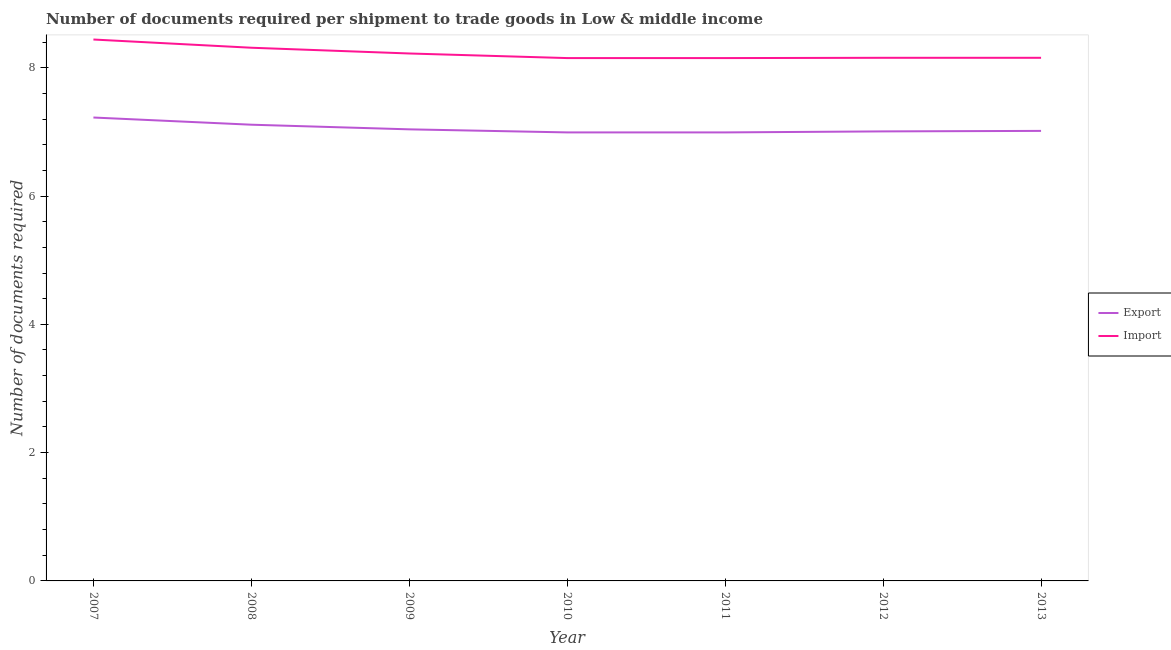How many different coloured lines are there?
Keep it short and to the point. 2. Does the line corresponding to number of documents required to import goods intersect with the line corresponding to number of documents required to export goods?
Make the answer very short. No. What is the number of documents required to export goods in 2009?
Provide a succinct answer. 7.04. Across all years, what is the maximum number of documents required to export goods?
Make the answer very short. 7.22. Across all years, what is the minimum number of documents required to import goods?
Ensure brevity in your answer.  8.15. In which year was the number of documents required to import goods minimum?
Make the answer very short. 2010. What is the total number of documents required to export goods in the graph?
Give a very brief answer. 49.38. What is the difference between the number of documents required to import goods in 2009 and that in 2013?
Your answer should be compact. 0.07. What is the difference between the number of documents required to export goods in 2012 and the number of documents required to import goods in 2007?
Keep it short and to the point. -1.43. What is the average number of documents required to import goods per year?
Your response must be concise. 8.23. In the year 2008, what is the difference between the number of documents required to export goods and number of documents required to import goods?
Offer a terse response. -1.2. In how many years, is the number of documents required to import goods greater than 2?
Give a very brief answer. 7. What is the ratio of the number of documents required to import goods in 2007 to that in 2010?
Ensure brevity in your answer.  1.04. Is the number of documents required to export goods in 2010 less than that in 2011?
Your answer should be compact. No. Is the difference between the number of documents required to export goods in 2008 and 2013 greater than the difference between the number of documents required to import goods in 2008 and 2013?
Your answer should be very brief. No. What is the difference between the highest and the second highest number of documents required to export goods?
Make the answer very short. 0.11. What is the difference between the highest and the lowest number of documents required to import goods?
Provide a short and direct response. 0.29. How many years are there in the graph?
Your response must be concise. 7. What is the difference between two consecutive major ticks on the Y-axis?
Make the answer very short. 2. Does the graph contain any zero values?
Offer a very short reply. No. Does the graph contain grids?
Ensure brevity in your answer.  No. What is the title of the graph?
Provide a short and direct response. Number of documents required per shipment to trade goods in Low & middle income. What is the label or title of the Y-axis?
Ensure brevity in your answer.  Number of documents required. What is the Number of documents required in Export in 2007?
Offer a terse response. 7.22. What is the Number of documents required of Import in 2007?
Provide a short and direct response. 8.44. What is the Number of documents required in Export in 2008?
Provide a short and direct response. 7.11. What is the Number of documents required in Import in 2008?
Your answer should be compact. 8.31. What is the Number of documents required in Export in 2009?
Provide a succinct answer. 7.04. What is the Number of documents required of Import in 2009?
Your answer should be very brief. 8.22. What is the Number of documents required of Export in 2010?
Offer a terse response. 6.99. What is the Number of documents required of Import in 2010?
Your answer should be compact. 8.15. What is the Number of documents required in Export in 2011?
Provide a short and direct response. 6.99. What is the Number of documents required in Import in 2011?
Your answer should be compact. 8.15. What is the Number of documents required of Export in 2012?
Make the answer very short. 7.01. What is the Number of documents required of Import in 2012?
Your response must be concise. 8.16. What is the Number of documents required in Export in 2013?
Keep it short and to the point. 7.02. What is the Number of documents required in Import in 2013?
Make the answer very short. 8.16. Across all years, what is the maximum Number of documents required of Export?
Provide a succinct answer. 7.22. Across all years, what is the maximum Number of documents required of Import?
Your answer should be very brief. 8.44. Across all years, what is the minimum Number of documents required of Export?
Offer a terse response. 6.99. Across all years, what is the minimum Number of documents required in Import?
Make the answer very short. 8.15. What is the total Number of documents required of Export in the graph?
Keep it short and to the point. 49.38. What is the total Number of documents required of Import in the graph?
Ensure brevity in your answer.  57.59. What is the difference between the Number of documents required in Export in 2007 and that in 2008?
Your response must be concise. 0.11. What is the difference between the Number of documents required of Import in 2007 and that in 2008?
Offer a terse response. 0.13. What is the difference between the Number of documents required in Export in 2007 and that in 2009?
Your answer should be very brief. 0.18. What is the difference between the Number of documents required in Import in 2007 and that in 2009?
Ensure brevity in your answer.  0.22. What is the difference between the Number of documents required in Export in 2007 and that in 2010?
Ensure brevity in your answer.  0.23. What is the difference between the Number of documents required of Import in 2007 and that in 2010?
Provide a short and direct response. 0.29. What is the difference between the Number of documents required of Export in 2007 and that in 2011?
Ensure brevity in your answer.  0.23. What is the difference between the Number of documents required in Import in 2007 and that in 2011?
Provide a short and direct response. 0.29. What is the difference between the Number of documents required of Export in 2007 and that in 2012?
Offer a very short reply. 0.22. What is the difference between the Number of documents required in Import in 2007 and that in 2012?
Make the answer very short. 0.28. What is the difference between the Number of documents required in Export in 2007 and that in 2013?
Make the answer very short. 0.21. What is the difference between the Number of documents required in Import in 2007 and that in 2013?
Your answer should be compact. 0.28. What is the difference between the Number of documents required of Export in 2008 and that in 2009?
Your answer should be compact. 0.07. What is the difference between the Number of documents required in Import in 2008 and that in 2009?
Offer a terse response. 0.09. What is the difference between the Number of documents required in Export in 2008 and that in 2010?
Give a very brief answer. 0.12. What is the difference between the Number of documents required of Import in 2008 and that in 2010?
Make the answer very short. 0.16. What is the difference between the Number of documents required of Export in 2008 and that in 2011?
Your response must be concise. 0.12. What is the difference between the Number of documents required of Import in 2008 and that in 2011?
Keep it short and to the point. 0.16. What is the difference between the Number of documents required of Export in 2008 and that in 2012?
Provide a short and direct response. 0.1. What is the difference between the Number of documents required in Import in 2008 and that in 2012?
Offer a very short reply. 0.16. What is the difference between the Number of documents required of Export in 2008 and that in 2013?
Make the answer very short. 0.1. What is the difference between the Number of documents required in Import in 2008 and that in 2013?
Provide a succinct answer. 0.16. What is the difference between the Number of documents required in Export in 2009 and that in 2010?
Provide a short and direct response. 0.05. What is the difference between the Number of documents required in Import in 2009 and that in 2010?
Offer a very short reply. 0.07. What is the difference between the Number of documents required of Export in 2009 and that in 2011?
Provide a short and direct response. 0.05. What is the difference between the Number of documents required in Import in 2009 and that in 2011?
Ensure brevity in your answer.  0.07. What is the difference between the Number of documents required of Export in 2009 and that in 2012?
Your answer should be very brief. 0.03. What is the difference between the Number of documents required in Import in 2009 and that in 2012?
Ensure brevity in your answer.  0.07. What is the difference between the Number of documents required in Export in 2009 and that in 2013?
Ensure brevity in your answer.  0.02. What is the difference between the Number of documents required in Import in 2009 and that in 2013?
Offer a terse response. 0.07. What is the difference between the Number of documents required in Export in 2010 and that in 2011?
Your answer should be compact. 0. What is the difference between the Number of documents required in Import in 2010 and that in 2011?
Make the answer very short. 0. What is the difference between the Number of documents required in Export in 2010 and that in 2012?
Offer a very short reply. -0.02. What is the difference between the Number of documents required in Import in 2010 and that in 2012?
Make the answer very short. -0. What is the difference between the Number of documents required in Export in 2010 and that in 2013?
Your answer should be compact. -0.02. What is the difference between the Number of documents required in Import in 2010 and that in 2013?
Your answer should be compact. -0. What is the difference between the Number of documents required in Export in 2011 and that in 2012?
Keep it short and to the point. -0.02. What is the difference between the Number of documents required of Import in 2011 and that in 2012?
Offer a very short reply. -0. What is the difference between the Number of documents required in Export in 2011 and that in 2013?
Make the answer very short. -0.02. What is the difference between the Number of documents required in Import in 2011 and that in 2013?
Offer a very short reply. -0. What is the difference between the Number of documents required in Export in 2012 and that in 2013?
Keep it short and to the point. -0.01. What is the difference between the Number of documents required in Export in 2007 and the Number of documents required in Import in 2008?
Your response must be concise. -1.09. What is the difference between the Number of documents required of Export in 2007 and the Number of documents required of Import in 2009?
Keep it short and to the point. -1. What is the difference between the Number of documents required of Export in 2007 and the Number of documents required of Import in 2010?
Provide a succinct answer. -0.93. What is the difference between the Number of documents required in Export in 2007 and the Number of documents required in Import in 2011?
Your response must be concise. -0.93. What is the difference between the Number of documents required of Export in 2007 and the Number of documents required of Import in 2012?
Your response must be concise. -0.93. What is the difference between the Number of documents required of Export in 2007 and the Number of documents required of Import in 2013?
Your answer should be compact. -0.93. What is the difference between the Number of documents required of Export in 2008 and the Number of documents required of Import in 2009?
Give a very brief answer. -1.11. What is the difference between the Number of documents required in Export in 2008 and the Number of documents required in Import in 2010?
Offer a terse response. -1.04. What is the difference between the Number of documents required of Export in 2008 and the Number of documents required of Import in 2011?
Give a very brief answer. -1.04. What is the difference between the Number of documents required of Export in 2008 and the Number of documents required of Import in 2012?
Provide a succinct answer. -1.04. What is the difference between the Number of documents required in Export in 2008 and the Number of documents required in Import in 2013?
Your answer should be very brief. -1.04. What is the difference between the Number of documents required of Export in 2009 and the Number of documents required of Import in 2010?
Provide a succinct answer. -1.11. What is the difference between the Number of documents required in Export in 2009 and the Number of documents required in Import in 2011?
Give a very brief answer. -1.11. What is the difference between the Number of documents required of Export in 2009 and the Number of documents required of Import in 2012?
Offer a very short reply. -1.12. What is the difference between the Number of documents required of Export in 2009 and the Number of documents required of Import in 2013?
Your response must be concise. -1.12. What is the difference between the Number of documents required in Export in 2010 and the Number of documents required in Import in 2011?
Make the answer very short. -1.16. What is the difference between the Number of documents required in Export in 2010 and the Number of documents required in Import in 2012?
Your answer should be compact. -1.16. What is the difference between the Number of documents required of Export in 2010 and the Number of documents required of Import in 2013?
Ensure brevity in your answer.  -1.16. What is the difference between the Number of documents required in Export in 2011 and the Number of documents required in Import in 2012?
Keep it short and to the point. -1.16. What is the difference between the Number of documents required of Export in 2011 and the Number of documents required of Import in 2013?
Provide a short and direct response. -1.16. What is the difference between the Number of documents required of Export in 2012 and the Number of documents required of Import in 2013?
Your answer should be very brief. -1.15. What is the average Number of documents required of Export per year?
Offer a very short reply. 7.05. What is the average Number of documents required of Import per year?
Offer a terse response. 8.23. In the year 2007, what is the difference between the Number of documents required in Export and Number of documents required in Import?
Your answer should be compact. -1.22. In the year 2008, what is the difference between the Number of documents required in Export and Number of documents required in Import?
Provide a short and direct response. -1.2. In the year 2009, what is the difference between the Number of documents required in Export and Number of documents required in Import?
Provide a succinct answer. -1.18. In the year 2010, what is the difference between the Number of documents required in Export and Number of documents required in Import?
Give a very brief answer. -1.16. In the year 2011, what is the difference between the Number of documents required of Export and Number of documents required of Import?
Your answer should be very brief. -1.16. In the year 2012, what is the difference between the Number of documents required of Export and Number of documents required of Import?
Your answer should be very brief. -1.15. In the year 2013, what is the difference between the Number of documents required of Export and Number of documents required of Import?
Provide a succinct answer. -1.14. What is the ratio of the Number of documents required in Export in 2007 to that in 2008?
Offer a very short reply. 1.02. What is the ratio of the Number of documents required of Import in 2007 to that in 2008?
Your answer should be compact. 1.02. What is the ratio of the Number of documents required in Export in 2007 to that in 2009?
Your answer should be very brief. 1.03. What is the ratio of the Number of documents required of Import in 2007 to that in 2009?
Provide a succinct answer. 1.03. What is the ratio of the Number of documents required of Export in 2007 to that in 2010?
Give a very brief answer. 1.03. What is the ratio of the Number of documents required in Import in 2007 to that in 2010?
Keep it short and to the point. 1.04. What is the ratio of the Number of documents required in Export in 2007 to that in 2011?
Offer a very short reply. 1.03. What is the ratio of the Number of documents required of Import in 2007 to that in 2011?
Your response must be concise. 1.04. What is the ratio of the Number of documents required in Export in 2007 to that in 2012?
Offer a very short reply. 1.03. What is the ratio of the Number of documents required in Import in 2007 to that in 2012?
Ensure brevity in your answer.  1.03. What is the ratio of the Number of documents required of Export in 2007 to that in 2013?
Make the answer very short. 1.03. What is the ratio of the Number of documents required in Import in 2007 to that in 2013?
Provide a succinct answer. 1.03. What is the ratio of the Number of documents required of Export in 2008 to that in 2009?
Ensure brevity in your answer.  1.01. What is the ratio of the Number of documents required in Import in 2008 to that in 2009?
Provide a short and direct response. 1.01. What is the ratio of the Number of documents required of Export in 2008 to that in 2010?
Provide a short and direct response. 1.02. What is the ratio of the Number of documents required in Import in 2008 to that in 2010?
Offer a very short reply. 1.02. What is the ratio of the Number of documents required of Export in 2008 to that in 2011?
Your answer should be compact. 1.02. What is the ratio of the Number of documents required in Import in 2008 to that in 2011?
Give a very brief answer. 1.02. What is the ratio of the Number of documents required of Export in 2008 to that in 2012?
Your response must be concise. 1.01. What is the ratio of the Number of documents required in Import in 2008 to that in 2012?
Your response must be concise. 1.02. What is the ratio of the Number of documents required in Export in 2008 to that in 2013?
Provide a short and direct response. 1.01. What is the ratio of the Number of documents required of Import in 2008 to that in 2013?
Your response must be concise. 1.02. What is the ratio of the Number of documents required in Export in 2009 to that in 2010?
Make the answer very short. 1.01. What is the ratio of the Number of documents required in Import in 2009 to that in 2010?
Provide a short and direct response. 1.01. What is the ratio of the Number of documents required of Export in 2009 to that in 2011?
Keep it short and to the point. 1.01. What is the ratio of the Number of documents required in Import in 2009 to that in 2011?
Provide a short and direct response. 1.01. What is the ratio of the Number of documents required in Import in 2009 to that in 2012?
Offer a very short reply. 1.01. What is the ratio of the Number of documents required in Export in 2009 to that in 2013?
Offer a very short reply. 1. What is the ratio of the Number of documents required of Import in 2009 to that in 2013?
Keep it short and to the point. 1.01. What is the ratio of the Number of documents required in Import in 2010 to that in 2013?
Make the answer very short. 1. What is the ratio of the Number of documents required in Import in 2011 to that in 2012?
Your answer should be very brief. 1. What is the ratio of the Number of documents required of Export in 2011 to that in 2013?
Your answer should be compact. 1. What is the ratio of the Number of documents required of Export in 2012 to that in 2013?
Make the answer very short. 1. What is the difference between the highest and the second highest Number of documents required in Export?
Make the answer very short. 0.11. What is the difference between the highest and the second highest Number of documents required in Import?
Make the answer very short. 0.13. What is the difference between the highest and the lowest Number of documents required in Export?
Make the answer very short. 0.23. What is the difference between the highest and the lowest Number of documents required of Import?
Offer a very short reply. 0.29. 